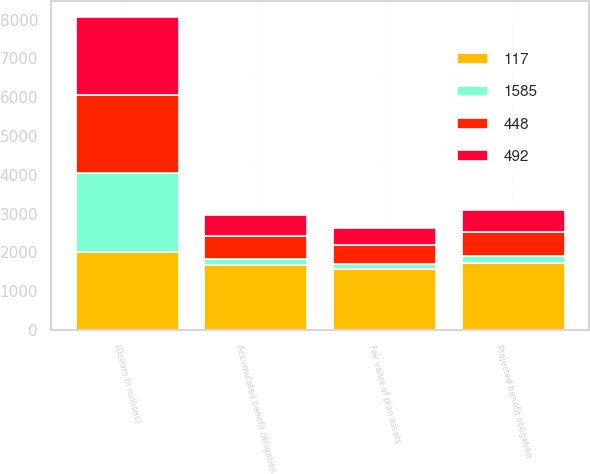<chart> <loc_0><loc_0><loc_500><loc_500><stacked_bar_chart><ecel><fcel>(Dollars in millions)<fcel>Projected benefit obligation<fcel>Accumulated benefit obligation<fcel>Fair value of plan assets<nl><fcel>117<fcel>2018<fcel>1726<fcel>1667<fcel>1585<nl><fcel>492<fcel>2018<fcel>568<fcel>547<fcel>448<nl><fcel>1585<fcel>2017<fcel>170<fcel>159<fcel>117<nl><fcel>448<fcel>2017<fcel>618<fcel>596<fcel>492<nl></chart> 